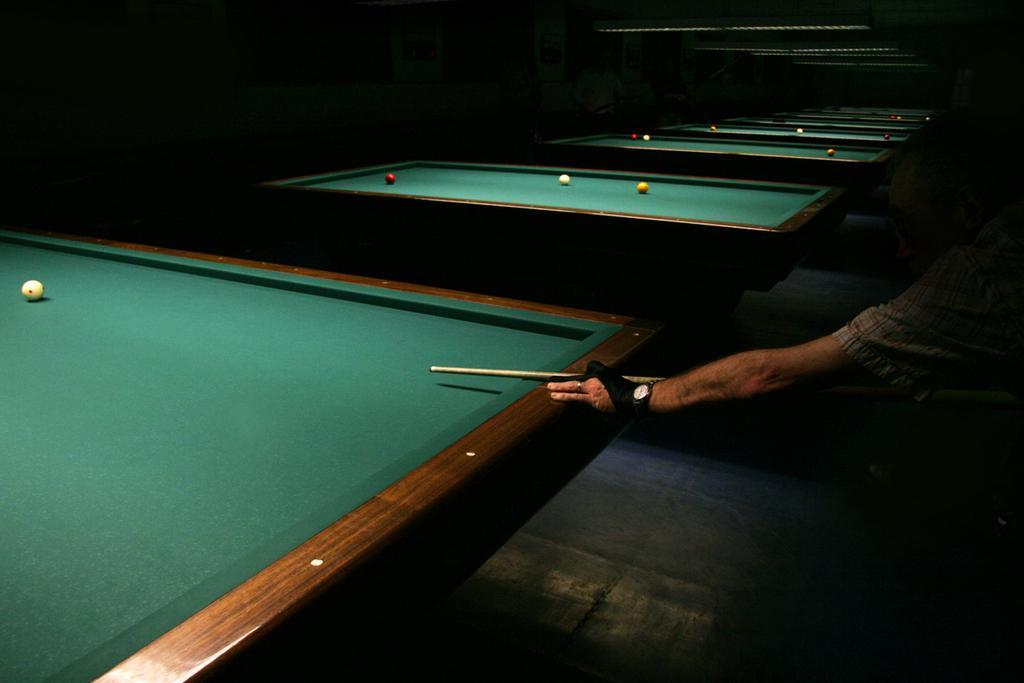Could you give a brief overview of what you see in this image? In this image we can see a person hand holding stick and playing billiards game. In the background we can see many billiard game tables. 